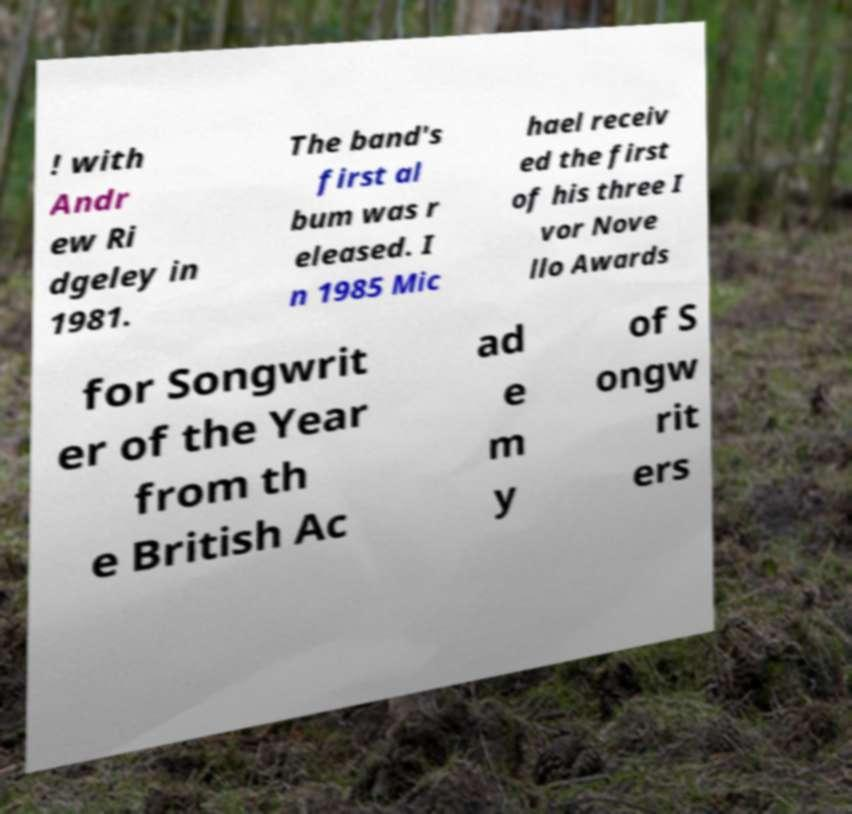Can you accurately transcribe the text from the provided image for me? ! with Andr ew Ri dgeley in 1981. The band's first al bum was r eleased. I n 1985 Mic hael receiv ed the first of his three I vor Nove llo Awards for Songwrit er of the Year from th e British Ac ad e m y of S ongw rit ers 